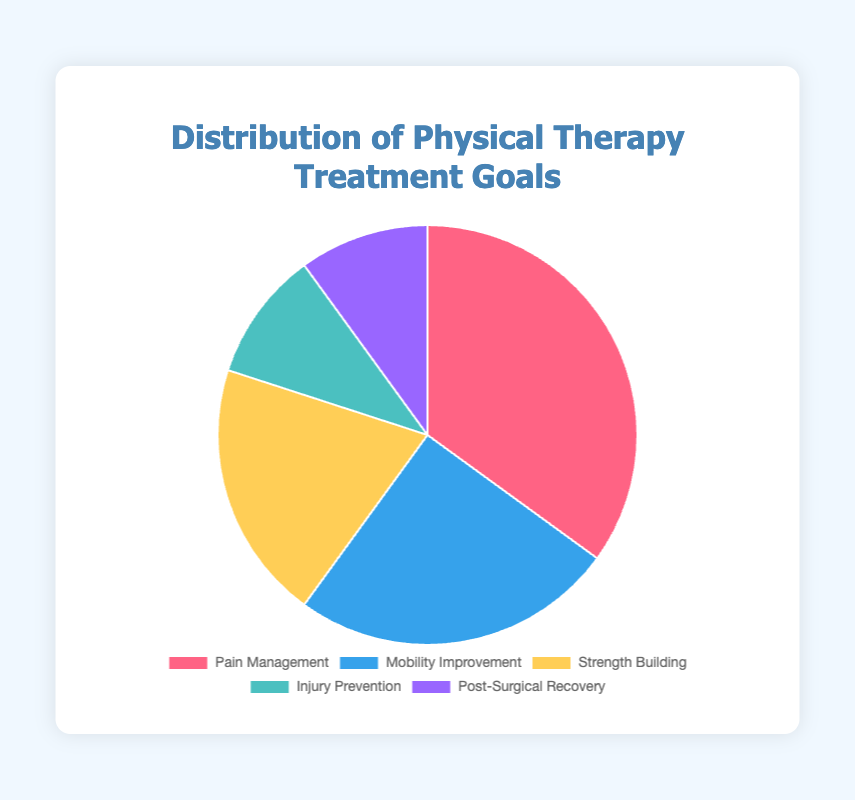What's the most common physical therapy treatment goal according to the pie chart? The segment representing "Pain Management" is the largest one, occupying 35% of the pie chart, which is the highest percentage among all categories.
Answer: Pain Management How much larger is the percentage of patients aiming for "Pain Management" compared to those aiming for "Strength Building"? The percentage for "Pain Management" is 35%, while for "Strength Building," it is 20%. The difference is 35% - 20% = 15%.
Answer: 15% Which two physical therapy treatment goals have the smallest representation in the pie chart? The segments for "Injury Prevention" and "Post-Surgical Recovery" are the smallest, each making up 10% of the pie chart.
Answer: Injury Prevention and Post-Surgical Recovery What percentage of patients have goals related to "Pain Management" and "Mobility Improvement" combined? "Pain Management" is 35% and "Mobility Improvement" is 25%. When combined, the total is 35% + 25% = 60%.
Answer: 60% What is the color used to represent "Mobility Improvement" in the pie chart? The segment for "Mobility Improvement" is colored blue.
Answer: blue Which goal has twice the representation of "Injury Prevention" in the pie chart? "Injury Prevention" is represented by 10%, and "Strength Building" is represented by 20%, which is twice the percentage of "Injury Prevention."
Answer: Strength Building What is the average percentage of the three most common treatment goals represented in the pie chart? The three most common goals are "Pain Management" (35%), "Mobility Improvement" (25%), and "Strength Building" (20%). Their average is (35% + 25% + 20%) / 3 = 80% / 3 ≈ 26.67%.
Answer: 26.67% Which segment is represented with a purple color? The "Post-Surgical Recovery" segment is shown in purple.
Answer: Post-Surgical Recovery What percentage of patients have goals other than "Pain Management"? The percentages for goals other than "Pain Management" are "Mobility Improvement" (25%), "Strength Building" (20%), "Injury Prevention" (10%), and "Post-Surgical Recovery" (10%). Their sum is 25% + 20% + 10% + 10% = 65%.
Answer: 65% Which goal shares the same percentage representation as "Post-Surgical Recovery"? "Injury Prevention," like "Post-Surgical Recovery," both have a representation of 10%.
Answer: Injury Prevention 